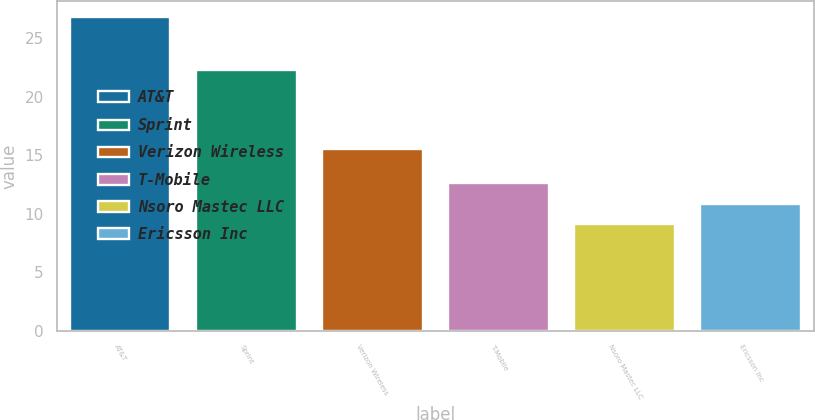Convert chart to OTSL. <chart><loc_0><loc_0><loc_500><loc_500><bar_chart><fcel>AT&T<fcel>Sprint<fcel>Verizon Wireless<fcel>T-Mobile<fcel>Nsoro Mastec LLC<fcel>Ericsson Inc<nl><fcel>26.8<fcel>22.3<fcel>15.5<fcel>12.64<fcel>9.1<fcel>10.87<nl></chart> 